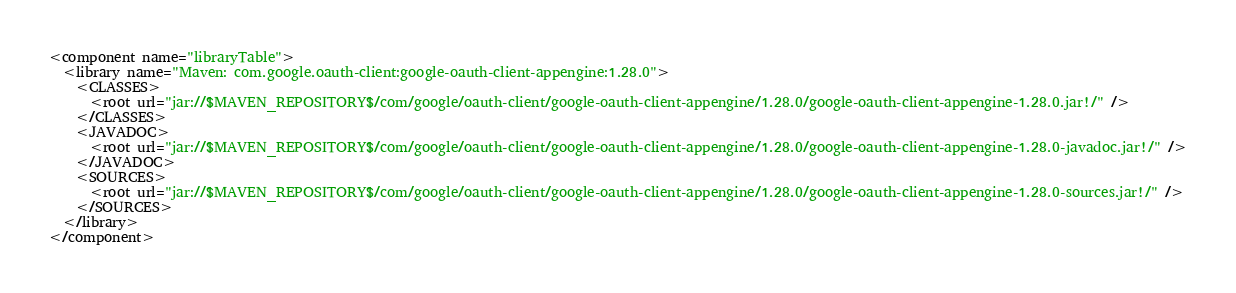Convert code to text. <code><loc_0><loc_0><loc_500><loc_500><_XML_><component name="libraryTable">
  <library name="Maven: com.google.oauth-client:google-oauth-client-appengine:1.28.0">
    <CLASSES>
      <root url="jar://$MAVEN_REPOSITORY$/com/google/oauth-client/google-oauth-client-appengine/1.28.0/google-oauth-client-appengine-1.28.0.jar!/" />
    </CLASSES>
    <JAVADOC>
      <root url="jar://$MAVEN_REPOSITORY$/com/google/oauth-client/google-oauth-client-appengine/1.28.0/google-oauth-client-appengine-1.28.0-javadoc.jar!/" />
    </JAVADOC>
    <SOURCES>
      <root url="jar://$MAVEN_REPOSITORY$/com/google/oauth-client/google-oauth-client-appengine/1.28.0/google-oauth-client-appengine-1.28.0-sources.jar!/" />
    </SOURCES>
  </library>
</component></code> 